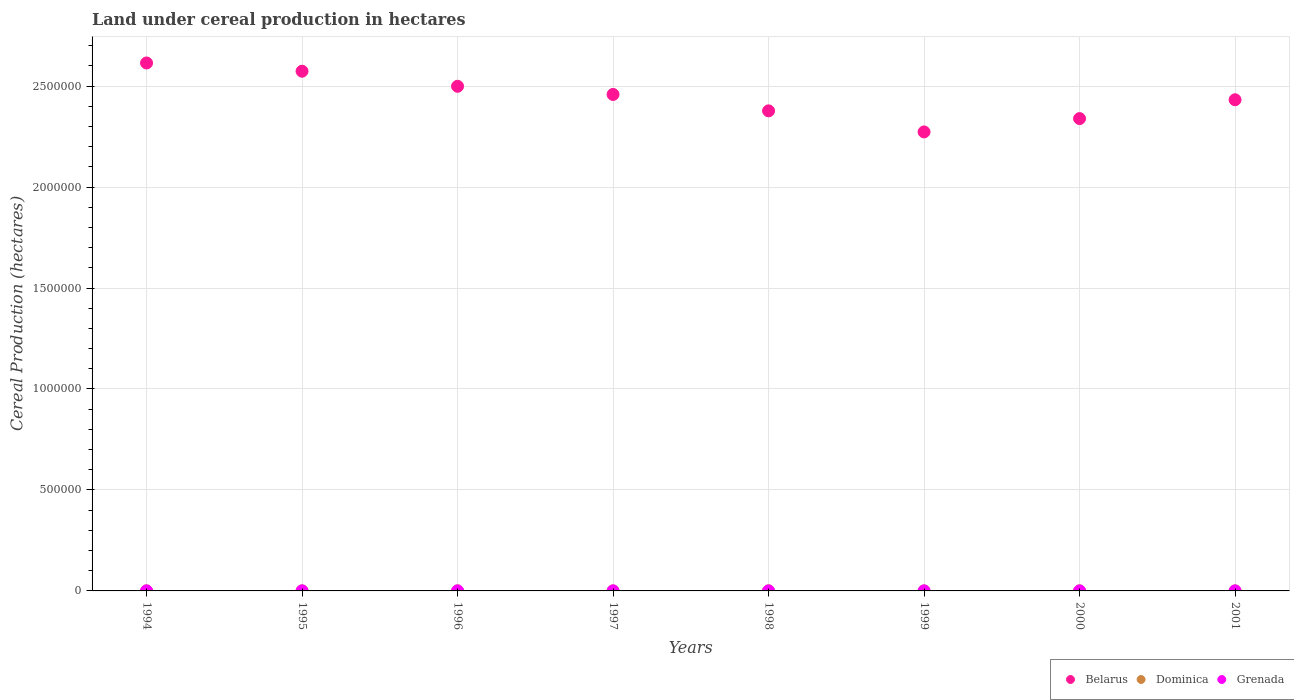How many different coloured dotlines are there?
Offer a terse response. 3. What is the land under cereal production in Belarus in 1994?
Make the answer very short. 2.61e+06. Across all years, what is the maximum land under cereal production in Grenada?
Ensure brevity in your answer.  360. Across all years, what is the minimum land under cereal production in Grenada?
Provide a short and direct response. 226. In which year was the land under cereal production in Belarus minimum?
Offer a very short reply. 1999. What is the total land under cereal production in Dominica in the graph?
Ensure brevity in your answer.  1189. What is the difference between the land under cereal production in Belarus in 1994 and that in 1997?
Make the answer very short. 1.56e+05. What is the difference between the land under cereal production in Grenada in 1998 and the land under cereal production in Dominica in 1996?
Your answer should be compact. 107. What is the average land under cereal production in Dominica per year?
Your response must be concise. 148.62. In the year 1995, what is the difference between the land under cereal production in Belarus and land under cereal production in Dominica?
Ensure brevity in your answer.  2.57e+06. What is the ratio of the land under cereal production in Grenada in 1995 to that in 1999?
Ensure brevity in your answer.  1.59. Is the land under cereal production in Dominica in 1999 less than that in 2000?
Offer a very short reply. Yes. Is the difference between the land under cereal production in Belarus in 1995 and 1998 greater than the difference between the land under cereal production in Dominica in 1995 and 1998?
Your response must be concise. Yes. What is the difference between the highest and the lowest land under cereal production in Dominica?
Give a very brief answer. 54. Is the sum of the land under cereal production in Grenada in 1995 and 1998 greater than the maximum land under cereal production in Dominica across all years?
Make the answer very short. Yes. Is it the case that in every year, the sum of the land under cereal production in Grenada and land under cereal production in Dominica  is greater than the land under cereal production in Belarus?
Provide a succinct answer. No. Does the land under cereal production in Dominica monotonically increase over the years?
Your answer should be very brief. No. Is the land under cereal production in Grenada strictly greater than the land under cereal production in Dominica over the years?
Ensure brevity in your answer.  Yes. How many years are there in the graph?
Give a very brief answer. 8. Are the values on the major ticks of Y-axis written in scientific E-notation?
Give a very brief answer. No. Does the graph contain grids?
Your answer should be very brief. Yes. Where does the legend appear in the graph?
Provide a short and direct response. Bottom right. What is the title of the graph?
Make the answer very short. Land under cereal production in hectares. Does "Afghanistan" appear as one of the legend labels in the graph?
Your answer should be very brief. No. What is the label or title of the Y-axis?
Offer a terse response. Cereal Production (hectares). What is the Cereal Production (hectares) in Belarus in 1994?
Offer a very short reply. 2.61e+06. What is the Cereal Production (hectares) of Dominica in 1994?
Ensure brevity in your answer.  130. What is the Cereal Production (hectares) in Grenada in 1994?
Your answer should be very brief. 350. What is the Cereal Production (hectares) in Belarus in 1995?
Provide a succinct answer. 2.57e+06. What is the Cereal Production (hectares) of Dominica in 1995?
Your answer should be compact. 131. What is the Cereal Production (hectares) of Grenada in 1995?
Offer a terse response. 360. What is the Cereal Production (hectares) of Belarus in 1996?
Provide a succinct answer. 2.50e+06. What is the Cereal Production (hectares) in Dominica in 1996?
Keep it short and to the point. 154. What is the Cereal Production (hectares) in Grenada in 1996?
Keep it short and to the point. 330. What is the Cereal Production (hectares) of Belarus in 1997?
Provide a short and direct response. 2.46e+06. What is the Cereal Production (hectares) of Dominica in 1997?
Offer a very short reply. 184. What is the Cereal Production (hectares) of Grenada in 1997?
Make the answer very short. 300. What is the Cereal Production (hectares) of Belarus in 1998?
Offer a terse response. 2.38e+06. What is the Cereal Production (hectares) in Dominica in 1998?
Keep it short and to the point. 160. What is the Cereal Production (hectares) in Grenada in 1998?
Offer a terse response. 261. What is the Cereal Production (hectares) of Belarus in 1999?
Your answer should be very brief. 2.27e+06. What is the Cereal Production (hectares) of Dominica in 1999?
Give a very brief answer. 139. What is the Cereal Production (hectares) in Grenada in 1999?
Make the answer very short. 226. What is the Cereal Production (hectares) of Belarus in 2000?
Make the answer very short. 2.34e+06. What is the Cereal Production (hectares) of Dominica in 2000?
Offer a terse response. 146. What is the Cereal Production (hectares) of Grenada in 2000?
Your answer should be very brief. 237. What is the Cereal Production (hectares) in Belarus in 2001?
Offer a terse response. 2.43e+06. What is the Cereal Production (hectares) of Dominica in 2001?
Make the answer very short. 145. What is the Cereal Production (hectares) in Grenada in 2001?
Ensure brevity in your answer.  235. Across all years, what is the maximum Cereal Production (hectares) in Belarus?
Make the answer very short. 2.61e+06. Across all years, what is the maximum Cereal Production (hectares) of Dominica?
Make the answer very short. 184. Across all years, what is the maximum Cereal Production (hectares) of Grenada?
Offer a very short reply. 360. Across all years, what is the minimum Cereal Production (hectares) of Belarus?
Provide a short and direct response. 2.27e+06. Across all years, what is the minimum Cereal Production (hectares) in Dominica?
Make the answer very short. 130. Across all years, what is the minimum Cereal Production (hectares) of Grenada?
Your response must be concise. 226. What is the total Cereal Production (hectares) in Belarus in the graph?
Offer a very short reply. 1.96e+07. What is the total Cereal Production (hectares) of Dominica in the graph?
Provide a succinct answer. 1189. What is the total Cereal Production (hectares) of Grenada in the graph?
Your response must be concise. 2299. What is the difference between the Cereal Production (hectares) of Belarus in 1994 and that in 1995?
Offer a terse response. 4.08e+04. What is the difference between the Cereal Production (hectares) of Grenada in 1994 and that in 1995?
Offer a terse response. -10. What is the difference between the Cereal Production (hectares) in Belarus in 1994 and that in 1996?
Provide a succinct answer. 1.15e+05. What is the difference between the Cereal Production (hectares) of Dominica in 1994 and that in 1996?
Keep it short and to the point. -24. What is the difference between the Cereal Production (hectares) in Belarus in 1994 and that in 1997?
Offer a very short reply. 1.56e+05. What is the difference between the Cereal Production (hectares) in Dominica in 1994 and that in 1997?
Provide a short and direct response. -54. What is the difference between the Cereal Production (hectares) in Belarus in 1994 and that in 1998?
Give a very brief answer. 2.37e+05. What is the difference between the Cereal Production (hectares) in Grenada in 1994 and that in 1998?
Your response must be concise. 89. What is the difference between the Cereal Production (hectares) in Belarus in 1994 and that in 1999?
Provide a succinct answer. 3.41e+05. What is the difference between the Cereal Production (hectares) of Grenada in 1994 and that in 1999?
Your answer should be very brief. 124. What is the difference between the Cereal Production (hectares) of Belarus in 1994 and that in 2000?
Keep it short and to the point. 2.75e+05. What is the difference between the Cereal Production (hectares) of Grenada in 1994 and that in 2000?
Ensure brevity in your answer.  113. What is the difference between the Cereal Production (hectares) in Belarus in 1994 and that in 2001?
Keep it short and to the point. 1.82e+05. What is the difference between the Cereal Production (hectares) of Dominica in 1994 and that in 2001?
Your answer should be very brief. -15. What is the difference between the Cereal Production (hectares) of Grenada in 1994 and that in 2001?
Make the answer very short. 115. What is the difference between the Cereal Production (hectares) of Belarus in 1995 and that in 1996?
Your answer should be compact. 7.46e+04. What is the difference between the Cereal Production (hectares) in Belarus in 1995 and that in 1997?
Your answer should be very brief. 1.15e+05. What is the difference between the Cereal Production (hectares) in Dominica in 1995 and that in 1997?
Ensure brevity in your answer.  -53. What is the difference between the Cereal Production (hectares) in Grenada in 1995 and that in 1997?
Provide a short and direct response. 60. What is the difference between the Cereal Production (hectares) of Belarus in 1995 and that in 1998?
Your answer should be compact. 1.96e+05. What is the difference between the Cereal Production (hectares) of Belarus in 1995 and that in 1999?
Provide a succinct answer. 3.01e+05. What is the difference between the Cereal Production (hectares) of Grenada in 1995 and that in 1999?
Make the answer very short. 134. What is the difference between the Cereal Production (hectares) in Belarus in 1995 and that in 2000?
Provide a succinct answer. 2.35e+05. What is the difference between the Cereal Production (hectares) of Dominica in 1995 and that in 2000?
Make the answer very short. -15. What is the difference between the Cereal Production (hectares) in Grenada in 1995 and that in 2000?
Ensure brevity in your answer.  123. What is the difference between the Cereal Production (hectares) of Belarus in 1995 and that in 2001?
Ensure brevity in your answer.  1.41e+05. What is the difference between the Cereal Production (hectares) in Dominica in 1995 and that in 2001?
Ensure brevity in your answer.  -14. What is the difference between the Cereal Production (hectares) in Grenada in 1995 and that in 2001?
Offer a terse response. 125. What is the difference between the Cereal Production (hectares) in Belarus in 1996 and that in 1997?
Make the answer very short. 4.05e+04. What is the difference between the Cereal Production (hectares) in Dominica in 1996 and that in 1997?
Your answer should be compact. -30. What is the difference between the Cereal Production (hectares) in Grenada in 1996 and that in 1997?
Make the answer very short. 30. What is the difference between the Cereal Production (hectares) of Belarus in 1996 and that in 1998?
Your answer should be compact. 1.22e+05. What is the difference between the Cereal Production (hectares) in Grenada in 1996 and that in 1998?
Your answer should be compact. 69. What is the difference between the Cereal Production (hectares) of Belarus in 1996 and that in 1999?
Offer a terse response. 2.26e+05. What is the difference between the Cereal Production (hectares) of Grenada in 1996 and that in 1999?
Make the answer very short. 104. What is the difference between the Cereal Production (hectares) in Belarus in 1996 and that in 2000?
Offer a very short reply. 1.60e+05. What is the difference between the Cereal Production (hectares) of Dominica in 1996 and that in 2000?
Make the answer very short. 8. What is the difference between the Cereal Production (hectares) in Grenada in 1996 and that in 2000?
Offer a terse response. 93. What is the difference between the Cereal Production (hectares) in Belarus in 1996 and that in 2001?
Offer a terse response. 6.68e+04. What is the difference between the Cereal Production (hectares) of Dominica in 1996 and that in 2001?
Ensure brevity in your answer.  9. What is the difference between the Cereal Production (hectares) of Grenada in 1996 and that in 2001?
Provide a short and direct response. 95. What is the difference between the Cereal Production (hectares) of Belarus in 1997 and that in 1998?
Ensure brevity in your answer.  8.12e+04. What is the difference between the Cereal Production (hectares) in Dominica in 1997 and that in 1998?
Your answer should be very brief. 24. What is the difference between the Cereal Production (hectares) in Grenada in 1997 and that in 1998?
Provide a succinct answer. 39. What is the difference between the Cereal Production (hectares) in Belarus in 1997 and that in 1999?
Offer a terse response. 1.86e+05. What is the difference between the Cereal Production (hectares) of Grenada in 1997 and that in 1999?
Your answer should be very brief. 74. What is the difference between the Cereal Production (hectares) of Belarus in 1997 and that in 2000?
Ensure brevity in your answer.  1.20e+05. What is the difference between the Cereal Production (hectares) in Grenada in 1997 and that in 2000?
Your answer should be compact. 63. What is the difference between the Cereal Production (hectares) in Belarus in 1997 and that in 2001?
Offer a very short reply. 2.63e+04. What is the difference between the Cereal Production (hectares) of Grenada in 1997 and that in 2001?
Your response must be concise. 65. What is the difference between the Cereal Production (hectares) of Belarus in 1998 and that in 1999?
Give a very brief answer. 1.04e+05. What is the difference between the Cereal Production (hectares) of Dominica in 1998 and that in 1999?
Provide a short and direct response. 21. What is the difference between the Cereal Production (hectares) in Belarus in 1998 and that in 2000?
Your answer should be very brief. 3.83e+04. What is the difference between the Cereal Production (hectares) of Dominica in 1998 and that in 2000?
Make the answer very short. 14. What is the difference between the Cereal Production (hectares) in Belarus in 1998 and that in 2001?
Ensure brevity in your answer.  -5.49e+04. What is the difference between the Cereal Production (hectares) of Belarus in 1999 and that in 2000?
Offer a terse response. -6.60e+04. What is the difference between the Cereal Production (hectares) in Belarus in 1999 and that in 2001?
Ensure brevity in your answer.  -1.59e+05. What is the difference between the Cereal Production (hectares) in Dominica in 1999 and that in 2001?
Offer a very short reply. -6. What is the difference between the Cereal Production (hectares) of Belarus in 2000 and that in 2001?
Ensure brevity in your answer.  -9.32e+04. What is the difference between the Cereal Production (hectares) of Belarus in 1994 and the Cereal Production (hectares) of Dominica in 1995?
Provide a succinct answer. 2.61e+06. What is the difference between the Cereal Production (hectares) of Belarus in 1994 and the Cereal Production (hectares) of Grenada in 1995?
Ensure brevity in your answer.  2.61e+06. What is the difference between the Cereal Production (hectares) in Dominica in 1994 and the Cereal Production (hectares) in Grenada in 1995?
Your answer should be compact. -230. What is the difference between the Cereal Production (hectares) in Belarus in 1994 and the Cereal Production (hectares) in Dominica in 1996?
Your response must be concise. 2.61e+06. What is the difference between the Cereal Production (hectares) of Belarus in 1994 and the Cereal Production (hectares) of Grenada in 1996?
Offer a very short reply. 2.61e+06. What is the difference between the Cereal Production (hectares) of Dominica in 1994 and the Cereal Production (hectares) of Grenada in 1996?
Your answer should be very brief. -200. What is the difference between the Cereal Production (hectares) of Belarus in 1994 and the Cereal Production (hectares) of Dominica in 1997?
Give a very brief answer. 2.61e+06. What is the difference between the Cereal Production (hectares) in Belarus in 1994 and the Cereal Production (hectares) in Grenada in 1997?
Offer a very short reply. 2.61e+06. What is the difference between the Cereal Production (hectares) in Dominica in 1994 and the Cereal Production (hectares) in Grenada in 1997?
Ensure brevity in your answer.  -170. What is the difference between the Cereal Production (hectares) in Belarus in 1994 and the Cereal Production (hectares) in Dominica in 1998?
Offer a terse response. 2.61e+06. What is the difference between the Cereal Production (hectares) of Belarus in 1994 and the Cereal Production (hectares) of Grenada in 1998?
Ensure brevity in your answer.  2.61e+06. What is the difference between the Cereal Production (hectares) of Dominica in 1994 and the Cereal Production (hectares) of Grenada in 1998?
Provide a succinct answer. -131. What is the difference between the Cereal Production (hectares) of Belarus in 1994 and the Cereal Production (hectares) of Dominica in 1999?
Provide a succinct answer. 2.61e+06. What is the difference between the Cereal Production (hectares) in Belarus in 1994 and the Cereal Production (hectares) in Grenada in 1999?
Provide a succinct answer. 2.61e+06. What is the difference between the Cereal Production (hectares) of Dominica in 1994 and the Cereal Production (hectares) of Grenada in 1999?
Offer a terse response. -96. What is the difference between the Cereal Production (hectares) of Belarus in 1994 and the Cereal Production (hectares) of Dominica in 2000?
Ensure brevity in your answer.  2.61e+06. What is the difference between the Cereal Production (hectares) of Belarus in 1994 and the Cereal Production (hectares) of Grenada in 2000?
Offer a terse response. 2.61e+06. What is the difference between the Cereal Production (hectares) in Dominica in 1994 and the Cereal Production (hectares) in Grenada in 2000?
Ensure brevity in your answer.  -107. What is the difference between the Cereal Production (hectares) of Belarus in 1994 and the Cereal Production (hectares) of Dominica in 2001?
Offer a terse response. 2.61e+06. What is the difference between the Cereal Production (hectares) in Belarus in 1994 and the Cereal Production (hectares) in Grenada in 2001?
Your response must be concise. 2.61e+06. What is the difference between the Cereal Production (hectares) in Dominica in 1994 and the Cereal Production (hectares) in Grenada in 2001?
Offer a very short reply. -105. What is the difference between the Cereal Production (hectares) in Belarus in 1995 and the Cereal Production (hectares) in Dominica in 1996?
Your response must be concise. 2.57e+06. What is the difference between the Cereal Production (hectares) of Belarus in 1995 and the Cereal Production (hectares) of Grenada in 1996?
Your answer should be compact. 2.57e+06. What is the difference between the Cereal Production (hectares) of Dominica in 1995 and the Cereal Production (hectares) of Grenada in 1996?
Your response must be concise. -199. What is the difference between the Cereal Production (hectares) in Belarus in 1995 and the Cereal Production (hectares) in Dominica in 1997?
Make the answer very short. 2.57e+06. What is the difference between the Cereal Production (hectares) of Belarus in 1995 and the Cereal Production (hectares) of Grenada in 1997?
Provide a succinct answer. 2.57e+06. What is the difference between the Cereal Production (hectares) in Dominica in 1995 and the Cereal Production (hectares) in Grenada in 1997?
Provide a short and direct response. -169. What is the difference between the Cereal Production (hectares) in Belarus in 1995 and the Cereal Production (hectares) in Dominica in 1998?
Offer a terse response. 2.57e+06. What is the difference between the Cereal Production (hectares) in Belarus in 1995 and the Cereal Production (hectares) in Grenada in 1998?
Offer a very short reply. 2.57e+06. What is the difference between the Cereal Production (hectares) of Dominica in 1995 and the Cereal Production (hectares) of Grenada in 1998?
Ensure brevity in your answer.  -130. What is the difference between the Cereal Production (hectares) of Belarus in 1995 and the Cereal Production (hectares) of Dominica in 1999?
Ensure brevity in your answer.  2.57e+06. What is the difference between the Cereal Production (hectares) in Belarus in 1995 and the Cereal Production (hectares) in Grenada in 1999?
Ensure brevity in your answer.  2.57e+06. What is the difference between the Cereal Production (hectares) of Dominica in 1995 and the Cereal Production (hectares) of Grenada in 1999?
Your answer should be very brief. -95. What is the difference between the Cereal Production (hectares) of Belarus in 1995 and the Cereal Production (hectares) of Dominica in 2000?
Ensure brevity in your answer.  2.57e+06. What is the difference between the Cereal Production (hectares) of Belarus in 1995 and the Cereal Production (hectares) of Grenada in 2000?
Your answer should be compact. 2.57e+06. What is the difference between the Cereal Production (hectares) in Dominica in 1995 and the Cereal Production (hectares) in Grenada in 2000?
Your answer should be very brief. -106. What is the difference between the Cereal Production (hectares) of Belarus in 1995 and the Cereal Production (hectares) of Dominica in 2001?
Provide a short and direct response. 2.57e+06. What is the difference between the Cereal Production (hectares) of Belarus in 1995 and the Cereal Production (hectares) of Grenada in 2001?
Your response must be concise. 2.57e+06. What is the difference between the Cereal Production (hectares) of Dominica in 1995 and the Cereal Production (hectares) of Grenada in 2001?
Provide a short and direct response. -104. What is the difference between the Cereal Production (hectares) of Belarus in 1996 and the Cereal Production (hectares) of Dominica in 1997?
Your response must be concise. 2.50e+06. What is the difference between the Cereal Production (hectares) of Belarus in 1996 and the Cereal Production (hectares) of Grenada in 1997?
Your answer should be compact. 2.50e+06. What is the difference between the Cereal Production (hectares) of Dominica in 1996 and the Cereal Production (hectares) of Grenada in 1997?
Your response must be concise. -146. What is the difference between the Cereal Production (hectares) of Belarus in 1996 and the Cereal Production (hectares) of Dominica in 1998?
Ensure brevity in your answer.  2.50e+06. What is the difference between the Cereal Production (hectares) of Belarus in 1996 and the Cereal Production (hectares) of Grenada in 1998?
Offer a very short reply. 2.50e+06. What is the difference between the Cereal Production (hectares) in Dominica in 1996 and the Cereal Production (hectares) in Grenada in 1998?
Provide a short and direct response. -107. What is the difference between the Cereal Production (hectares) of Belarus in 1996 and the Cereal Production (hectares) of Dominica in 1999?
Your answer should be very brief. 2.50e+06. What is the difference between the Cereal Production (hectares) in Belarus in 1996 and the Cereal Production (hectares) in Grenada in 1999?
Your answer should be very brief. 2.50e+06. What is the difference between the Cereal Production (hectares) in Dominica in 1996 and the Cereal Production (hectares) in Grenada in 1999?
Your answer should be compact. -72. What is the difference between the Cereal Production (hectares) in Belarus in 1996 and the Cereal Production (hectares) in Dominica in 2000?
Offer a terse response. 2.50e+06. What is the difference between the Cereal Production (hectares) of Belarus in 1996 and the Cereal Production (hectares) of Grenada in 2000?
Your answer should be very brief. 2.50e+06. What is the difference between the Cereal Production (hectares) in Dominica in 1996 and the Cereal Production (hectares) in Grenada in 2000?
Provide a short and direct response. -83. What is the difference between the Cereal Production (hectares) of Belarus in 1996 and the Cereal Production (hectares) of Dominica in 2001?
Offer a very short reply. 2.50e+06. What is the difference between the Cereal Production (hectares) in Belarus in 1996 and the Cereal Production (hectares) in Grenada in 2001?
Ensure brevity in your answer.  2.50e+06. What is the difference between the Cereal Production (hectares) of Dominica in 1996 and the Cereal Production (hectares) of Grenada in 2001?
Keep it short and to the point. -81. What is the difference between the Cereal Production (hectares) in Belarus in 1997 and the Cereal Production (hectares) in Dominica in 1998?
Give a very brief answer. 2.46e+06. What is the difference between the Cereal Production (hectares) in Belarus in 1997 and the Cereal Production (hectares) in Grenada in 1998?
Keep it short and to the point. 2.46e+06. What is the difference between the Cereal Production (hectares) in Dominica in 1997 and the Cereal Production (hectares) in Grenada in 1998?
Give a very brief answer. -77. What is the difference between the Cereal Production (hectares) of Belarus in 1997 and the Cereal Production (hectares) of Dominica in 1999?
Ensure brevity in your answer.  2.46e+06. What is the difference between the Cereal Production (hectares) in Belarus in 1997 and the Cereal Production (hectares) in Grenada in 1999?
Your response must be concise. 2.46e+06. What is the difference between the Cereal Production (hectares) of Dominica in 1997 and the Cereal Production (hectares) of Grenada in 1999?
Your answer should be very brief. -42. What is the difference between the Cereal Production (hectares) in Belarus in 1997 and the Cereal Production (hectares) in Dominica in 2000?
Provide a short and direct response. 2.46e+06. What is the difference between the Cereal Production (hectares) of Belarus in 1997 and the Cereal Production (hectares) of Grenada in 2000?
Ensure brevity in your answer.  2.46e+06. What is the difference between the Cereal Production (hectares) of Dominica in 1997 and the Cereal Production (hectares) of Grenada in 2000?
Offer a very short reply. -53. What is the difference between the Cereal Production (hectares) of Belarus in 1997 and the Cereal Production (hectares) of Dominica in 2001?
Keep it short and to the point. 2.46e+06. What is the difference between the Cereal Production (hectares) of Belarus in 1997 and the Cereal Production (hectares) of Grenada in 2001?
Your answer should be compact. 2.46e+06. What is the difference between the Cereal Production (hectares) in Dominica in 1997 and the Cereal Production (hectares) in Grenada in 2001?
Your answer should be very brief. -51. What is the difference between the Cereal Production (hectares) of Belarus in 1998 and the Cereal Production (hectares) of Dominica in 1999?
Provide a succinct answer. 2.38e+06. What is the difference between the Cereal Production (hectares) in Belarus in 1998 and the Cereal Production (hectares) in Grenada in 1999?
Provide a short and direct response. 2.38e+06. What is the difference between the Cereal Production (hectares) in Dominica in 1998 and the Cereal Production (hectares) in Grenada in 1999?
Offer a terse response. -66. What is the difference between the Cereal Production (hectares) in Belarus in 1998 and the Cereal Production (hectares) in Dominica in 2000?
Ensure brevity in your answer.  2.38e+06. What is the difference between the Cereal Production (hectares) of Belarus in 1998 and the Cereal Production (hectares) of Grenada in 2000?
Your answer should be compact. 2.38e+06. What is the difference between the Cereal Production (hectares) of Dominica in 1998 and the Cereal Production (hectares) of Grenada in 2000?
Offer a very short reply. -77. What is the difference between the Cereal Production (hectares) of Belarus in 1998 and the Cereal Production (hectares) of Dominica in 2001?
Provide a short and direct response. 2.38e+06. What is the difference between the Cereal Production (hectares) of Belarus in 1998 and the Cereal Production (hectares) of Grenada in 2001?
Ensure brevity in your answer.  2.38e+06. What is the difference between the Cereal Production (hectares) in Dominica in 1998 and the Cereal Production (hectares) in Grenada in 2001?
Keep it short and to the point. -75. What is the difference between the Cereal Production (hectares) of Belarus in 1999 and the Cereal Production (hectares) of Dominica in 2000?
Give a very brief answer. 2.27e+06. What is the difference between the Cereal Production (hectares) in Belarus in 1999 and the Cereal Production (hectares) in Grenada in 2000?
Give a very brief answer. 2.27e+06. What is the difference between the Cereal Production (hectares) of Dominica in 1999 and the Cereal Production (hectares) of Grenada in 2000?
Give a very brief answer. -98. What is the difference between the Cereal Production (hectares) of Belarus in 1999 and the Cereal Production (hectares) of Dominica in 2001?
Ensure brevity in your answer.  2.27e+06. What is the difference between the Cereal Production (hectares) of Belarus in 1999 and the Cereal Production (hectares) of Grenada in 2001?
Make the answer very short. 2.27e+06. What is the difference between the Cereal Production (hectares) in Dominica in 1999 and the Cereal Production (hectares) in Grenada in 2001?
Provide a short and direct response. -96. What is the difference between the Cereal Production (hectares) in Belarus in 2000 and the Cereal Production (hectares) in Dominica in 2001?
Provide a succinct answer. 2.34e+06. What is the difference between the Cereal Production (hectares) in Belarus in 2000 and the Cereal Production (hectares) in Grenada in 2001?
Your answer should be compact. 2.34e+06. What is the difference between the Cereal Production (hectares) of Dominica in 2000 and the Cereal Production (hectares) of Grenada in 2001?
Make the answer very short. -89. What is the average Cereal Production (hectares) in Belarus per year?
Keep it short and to the point. 2.45e+06. What is the average Cereal Production (hectares) of Dominica per year?
Provide a succinct answer. 148.62. What is the average Cereal Production (hectares) in Grenada per year?
Your answer should be compact. 287.38. In the year 1994, what is the difference between the Cereal Production (hectares) in Belarus and Cereal Production (hectares) in Dominica?
Keep it short and to the point. 2.61e+06. In the year 1994, what is the difference between the Cereal Production (hectares) in Belarus and Cereal Production (hectares) in Grenada?
Your answer should be very brief. 2.61e+06. In the year 1994, what is the difference between the Cereal Production (hectares) of Dominica and Cereal Production (hectares) of Grenada?
Provide a short and direct response. -220. In the year 1995, what is the difference between the Cereal Production (hectares) in Belarus and Cereal Production (hectares) in Dominica?
Ensure brevity in your answer.  2.57e+06. In the year 1995, what is the difference between the Cereal Production (hectares) of Belarus and Cereal Production (hectares) of Grenada?
Give a very brief answer. 2.57e+06. In the year 1995, what is the difference between the Cereal Production (hectares) of Dominica and Cereal Production (hectares) of Grenada?
Your answer should be very brief. -229. In the year 1996, what is the difference between the Cereal Production (hectares) of Belarus and Cereal Production (hectares) of Dominica?
Offer a terse response. 2.50e+06. In the year 1996, what is the difference between the Cereal Production (hectares) of Belarus and Cereal Production (hectares) of Grenada?
Give a very brief answer. 2.50e+06. In the year 1996, what is the difference between the Cereal Production (hectares) of Dominica and Cereal Production (hectares) of Grenada?
Make the answer very short. -176. In the year 1997, what is the difference between the Cereal Production (hectares) in Belarus and Cereal Production (hectares) in Dominica?
Provide a short and direct response. 2.46e+06. In the year 1997, what is the difference between the Cereal Production (hectares) of Belarus and Cereal Production (hectares) of Grenada?
Provide a succinct answer. 2.46e+06. In the year 1997, what is the difference between the Cereal Production (hectares) of Dominica and Cereal Production (hectares) of Grenada?
Your answer should be compact. -116. In the year 1998, what is the difference between the Cereal Production (hectares) of Belarus and Cereal Production (hectares) of Dominica?
Your answer should be very brief. 2.38e+06. In the year 1998, what is the difference between the Cereal Production (hectares) in Belarus and Cereal Production (hectares) in Grenada?
Provide a short and direct response. 2.38e+06. In the year 1998, what is the difference between the Cereal Production (hectares) in Dominica and Cereal Production (hectares) in Grenada?
Your answer should be very brief. -101. In the year 1999, what is the difference between the Cereal Production (hectares) of Belarus and Cereal Production (hectares) of Dominica?
Your response must be concise. 2.27e+06. In the year 1999, what is the difference between the Cereal Production (hectares) in Belarus and Cereal Production (hectares) in Grenada?
Your answer should be compact. 2.27e+06. In the year 1999, what is the difference between the Cereal Production (hectares) in Dominica and Cereal Production (hectares) in Grenada?
Offer a very short reply. -87. In the year 2000, what is the difference between the Cereal Production (hectares) in Belarus and Cereal Production (hectares) in Dominica?
Make the answer very short. 2.34e+06. In the year 2000, what is the difference between the Cereal Production (hectares) in Belarus and Cereal Production (hectares) in Grenada?
Make the answer very short. 2.34e+06. In the year 2000, what is the difference between the Cereal Production (hectares) of Dominica and Cereal Production (hectares) of Grenada?
Keep it short and to the point. -91. In the year 2001, what is the difference between the Cereal Production (hectares) in Belarus and Cereal Production (hectares) in Dominica?
Your answer should be compact. 2.43e+06. In the year 2001, what is the difference between the Cereal Production (hectares) in Belarus and Cereal Production (hectares) in Grenada?
Your response must be concise. 2.43e+06. In the year 2001, what is the difference between the Cereal Production (hectares) of Dominica and Cereal Production (hectares) of Grenada?
Offer a very short reply. -90. What is the ratio of the Cereal Production (hectares) in Belarus in 1994 to that in 1995?
Give a very brief answer. 1.02. What is the ratio of the Cereal Production (hectares) of Grenada in 1994 to that in 1995?
Make the answer very short. 0.97. What is the ratio of the Cereal Production (hectares) of Belarus in 1994 to that in 1996?
Your answer should be very brief. 1.05. What is the ratio of the Cereal Production (hectares) of Dominica in 1994 to that in 1996?
Ensure brevity in your answer.  0.84. What is the ratio of the Cereal Production (hectares) in Grenada in 1994 to that in 1996?
Your answer should be very brief. 1.06. What is the ratio of the Cereal Production (hectares) in Belarus in 1994 to that in 1997?
Keep it short and to the point. 1.06. What is the ratio of the Cereal Production (hectares) in Dominica in 1994 to that in 1997?
Keep it short and to the point. 0.71. What is the ratio of the Cereal Production (hectares) of Grenada in 1994 to that in 1997?
Your answer should be very brief. 1.17. What is the ratio of the Cereal Production (hectares) in Belarus in 1994 to that in 1998?
Ensure brevity in your answer.  1.1. What is the ratio of the Cereal Production (hectares) of Dominica in 1994 to that in 1998?
Your response must be concise. 0.81. What is the ratio of the Cereal Production (hectares) of Grenada in 1994 to that in 1998?
Your answer should be compact. 1.34. What is the ratio of the Cereal Production (hectares) of Belarus in 1994 to that in 1999?
Offer a terse response. 1.15. What is the ratio of the Cereal Production (hectares) in Dominica in 1994 to that in 1999?
Provide a short and direct response. 0.94. What is the ratio of the Cereal Production (hectares) in Grenada in 1994 to that in 1999?
Ensure brevity in your answer.  1.55. What is the ratio of the Cereal Production (hectares) in Belarus in 1994 to that in 2000?
Provide a succinct answer. 1.12. What is the ratio of the Cereal Production (hectares) of Dominica in 1994 to that in 2000?
Offer a very short reply. 0.89. What is the ratio of the Cereal Production (hectares) in Grenada in 1994 to that in 2000?
Keep it short and to the point. 1.48. What is the ratio of the Cereal Production (hectares) of Belarus in 1994 to that in 2001?
Offer a very short reply. 1.07. What is the ratio of the Cereal Production (hectares) in Dominica in 1994 to that in 2001?
Offer a terse response. 0.9. What is the ratio of the Cereal Production (hectares) in Grenada in 1994 to that in 2001?
Offer a very short reply. 1.49. What is the ratio of the Cereal Production (hectares) of Belarus in 1995 to that in 1996?
Offer a very short reply. 1.03. What is the ratio of the Cereal Production (hectares) of Dominica in 1995 to that in 1996?
Your answer should be compact. 0.85. What is the ratio of the Cereal Production (hectares) in Belarus in 1995 to that in 1997?
Your answer should be compact. 1.05. What is the ratio of the Cereal Production (hectares) of Dominica in 1995 to that in 1997?
Keep it short and to the point. 0.71. What is the ratio of the Cereal Production (hectares) of Grenada in 1995 to that in 1997?
Provide a short and direct response. 1.2. What is the ratio of the Cereal Production (hectares) of Belarus in 1995 to that in 1998?
Your response must be concise. 1.08. What is the ratio of the Cereal Production (hectares) of Dominica in 1995 to that in 1998?
Offer a very short reply. 0.82. What is the ratio of the Cereal Production (hectares) of Grenada in 1995 to that in 1998?
Your answer should be very brief. 1.38. What is the ratio of the Cereal Production (hectares) of Belarus in 1995 to that in 1999?
Provide a succinct answer. 1.13. What is the ratio of the Cereal Production (hectares) in Dominica in 1995 to that in 1999?
Ensure brevity in your answer.  0.94. What is the ratio of the Cereal Production (hectares) in Grenada in 1995 to that in 1999?
Make the answer very short. 1.59. What is the ratio of the Cereal Production (hectares) of Belarus in 1995 to that in 2000?
Make the answer very short. 1.1. What is the ratio of the Cereal Production (hectares) of Dominica in 1995 to that in 2000?
Ensure brevity in your answer.  0.9. What is the ratio of the Cereal Production (hectares) of Grenada in 1995 to that in 2000?
Offer a very short reply. 1.52. What is the ratio of the Cereal Production (hectares) in Belarus in 1995 to that in 2001?
Provide a succinct answer. 1.06. What is the ratio of the Cereal Production (hectares) in Dominica in 1995 to that in 2001?
Your response must be concise. 0.9. What is the ratio of the Cereal Production (hectares) of Grenada in 1995 to that in 2001?
Keep it short and to the point. 1.53. What is the ratio of the Cereal Production (hectares) of Belarus in 1996 to that in 1997?
Make the answer very short. 1.02. What is the ratio of the Cereal Production (hectares) in Dominica in 1996 to that in 1997?
Keep it short and to the point. 0.84. What is the ratio of the Cereal Production (hectares) of Grenada in 1996 to that in 1997?
Your answer should be very brief. 1.1. What is the ratio of the Cereal Production (hectares) in Belarus in 1996 to that in 1998?
Your response must be concise. 1.05. What is the ratio of the Cereal Production (hectares) in Dominica in 1996 to that in 1998?
Keep it short and to the point. 0.96. What is the ratio of the Cereal Production (hectares) of Grenada in 1996 to that in 1998?
Keep it short and to the point. 1.26. What is the ratio of the Cereal Production (hectares) in Belarus in 1996 to that in 1999?
Provide a succinct answer. 1.1. What is the ratio of the Cereal Production (hectares) in Dominica in 1996 to that in 1999?
Provide a short and direct response. 1.11. What is the ratio of the Cereal Production (hectares) in Grenada in 1996 to that in 1999?
Keep it short and to the point. 1.46. What is the ratio of the Cereal Production (hectares) in Belarus in 1996 to that in 2000?
Your answer should be compact. 1.07. What is the ratio of the Cereal Production (hectares) of Dominica in 1996 to that in 2000?
Your answer should be compact. 1.05. What is the ratio of the Cereal Production (hectares) of Grenada in 1996 to that in 2000?
Offer a terse response. 1.39. What is the ratio of the Cereal Production (hectares) in Belarus in 1996 to that in 2001?
Make the answer very short. 1.03. What is the ratio of the Cereal Production (hectares) in Dominica in 1996 to that in 2001?
Make the answer very short. 1.06. What is the ratio of the Cereal Production (hectares) of Grenada in 1996 to that in 2001?
Provide a succinct answer. 1.4. What is the ratio of the Cereal Production (hectares) in Belarus in 1997 to that in 1998?
Offer a terse response. 1.03. What is the ratio of the Cereal Production (hectares) in Dominica in 1997 to that in 1998?
Provide a succinct answer. 1.15. What is the ratio of the Cereal Production (hectares) of Grenada in 1997 to that in 1998?
Ensure brevity in your answer.  1.15. What is the ratio of the Cereal Production (hectares) of Belarus in 1997 to that in 1999?
Provide a succinct answer. 1.08. What is the ratio of the Cereal Production (hectares) in Dominica in 1997 to that in 1999?
Offer a very short reply. 1.32. What is the ratio of the Cereal Production (hectares) of Grenada in 1997 to that in 1999?
Give a very brief answer. 1.33. What is the ratio of the Cereal Production (hectares) in Belarus in 1997 to that in 2000?
Provide a succinct answer. 1.05. What is the ratio of the Cereal Production (hectares) of Dominica in 1997 to that in 2000?
Keep it short and to the point. 1.26. What is the ratio of the Cereal Production (hectares) in Grenada in 1997 to that in 2000?
Offer a very short reply. 1.27. What is the ratio of the Cereal Production (hectares) in Belarus in 1997 to that in 2001?
Your answer should be compact. 1.01. What is the ratio of the Cereal Production (hectares) in Dominica in 1997 to that in 2001?
Provide a succinct answer. 1.27. What is the ratio of the Cereal Production (hectares) of Grenada in 1997 to that in 2001?
Provide a short and direct response. 1.28. What is the ratio of the Cereal Production (hectares) in Belarus in 1998 to that in 1999?
Your answer should be compact. 1.05. What is the ratio of the Cereal Production (hectares) in Dominica in 1998 to that in 1999?
Provide a succinct answer. 1.15. What is the ratio of the Cereal Production (hectares) in Grenada in 1998 to that in 1999?
Your answer should be compact. 1.15. What is the ratio of the Cereal Production (hectares) of Belarus in 1998 to that in 2000?
Provide a short and direct response. 1.02. What is the ratio of the Cereal Production (hectares) in Dominica in 1998 to that in 2000?
Offer a very short reply. 1.1. What is the ratio of the Cereal Production (hectares) in Grenada in 1998 to that in 2000?
Your answer should be compact. 1.1. What is the ratio of the Cereal Production (hectares) of Belarus in 1998 to that in 2001?
Your answer should be very brief. 0.98. What is the ratio of the Cereal Production (hectares) in Dominica in 1998 to that in 2001?
Give a very brief answer. 1.1. What is the ratio of the Cereal Production (hectares) in Grenada in 1998 to that in 2001?
Your answer should be compact. 1.11. What is the ratio of the Cereal Production (hectares) in Belarus in 1999 to that in 2000?
Give a very brief answer. 0.97. What is the ratio of the Cereal Production (hectares) in Dominica in 1999 to that in 2000?
Keep it short and to the point. 0.95. What is the ratio of the Cereal Production (hectares) of Grenada in 1999 to that in 2000?
Provide a short and direct response. 0.95. What is the ratio of the Cereal Production (hectares) in Belarus in 1999 to that in 2001?
Ensure brevity in your answer.  0.93. What is the ratio of the Cereal Production (hectares) in Dominica in 1999 to that in 2001?
Ensure brevity in your answer.  0.96. What is the ratio of the Cereal Production (hectares) in Grenada in 1999 to that in 2001?
Provide a succinct answer. 0.96. What is the ratio of the Cereal Production (hectares) in Belarus in 2000 to that in 2001?
Make the answer very short. 0.96. What is the ratio of the Cereal Production (hectares) of Grenada in 2000 to that in 2001?
Your response must be concise. 1.01. What is the difference between the highest and the second highest Cereal Production (hectares) in Belarus?
Offer a terse response. 4.08e+04. What is the difference between the highest and the second highest Cereal Production (hectares) in Dominica?
Give a very brief answer. 24. What is the difference between the highest and the second highest Cereal Production (hectares) in Grenada?
Provide a short and direct response. 10. What is the difference between the highest and the lowest Cereal Production (hectares) of Belarus?
Make the answer very short. 3.41e+05. What is the difference between the highest and the lowest Cereal Production (hectares) in Dominica?
Give a very brief answer. 54. What is the difference between the highest and the lowest Cereal Production (hectares) of Grenada?
Provide a succinct answer. 134. 